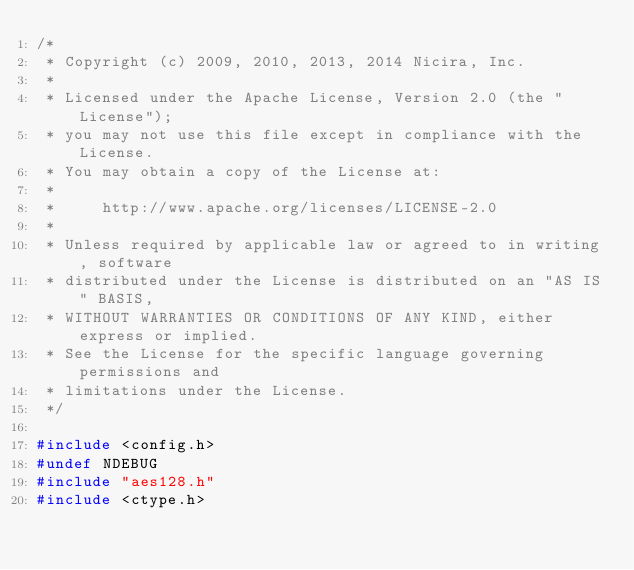<code> <loc_0><loc_0><loc_500><loc_500><_C_>/*
 * Copyright (c) 2009, 2010, 2013, 2014 Nicira, Inc.
 *
 * Licensed under the Apache License, Version 2.0 (the "License");
 * you may not use this file except in compliance with the License.
 * You may obtain a copy of the License at:
 *
 *     http://www.apache.org/licenses/LICENSE-2.0
 *
 * Unless required by applicable law or agreed to in writing, software
 * distributed under the License is distributed on an "AS IS" BASIS,
 * WITHOUT WARRANTIES OR CONDITIONS OF ANY KIND, either express or implied.
 * See the License for the specific language governing permissions and
 * limitations under the License.
 */

#include <config.h>
#undef NDEBUG
#include "aes128.h"
#include <ctype.h></code> 